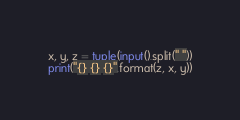Convert code to text. <code><loc_0><loc_0><loc_500><loc_500><_Python_>x, y, z = tuple(input().split(" "))
print("{} {} {}".format(z, x, y))</code> 